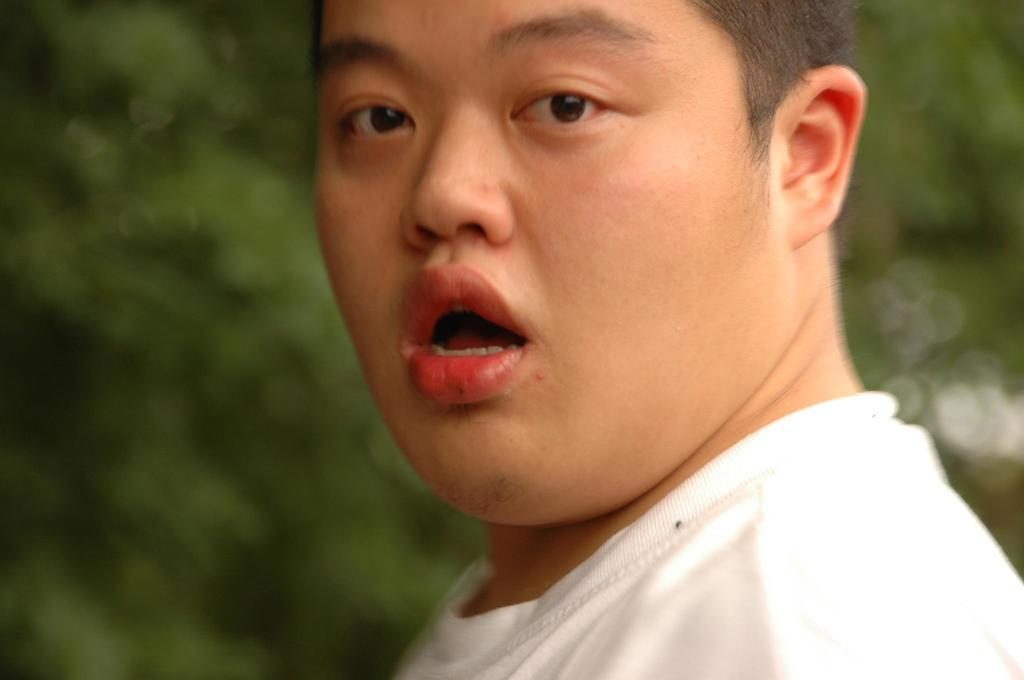Who is present in the image? There is a man in the image. What is the man wearing? The man is wearing a white t-shirt. Can you describe the background of the image? The background of the image is blurred. What type of air attack is happening in the image? There is no air attack present in the image; it features a man wearing a white t-shirt with a blurred background. 